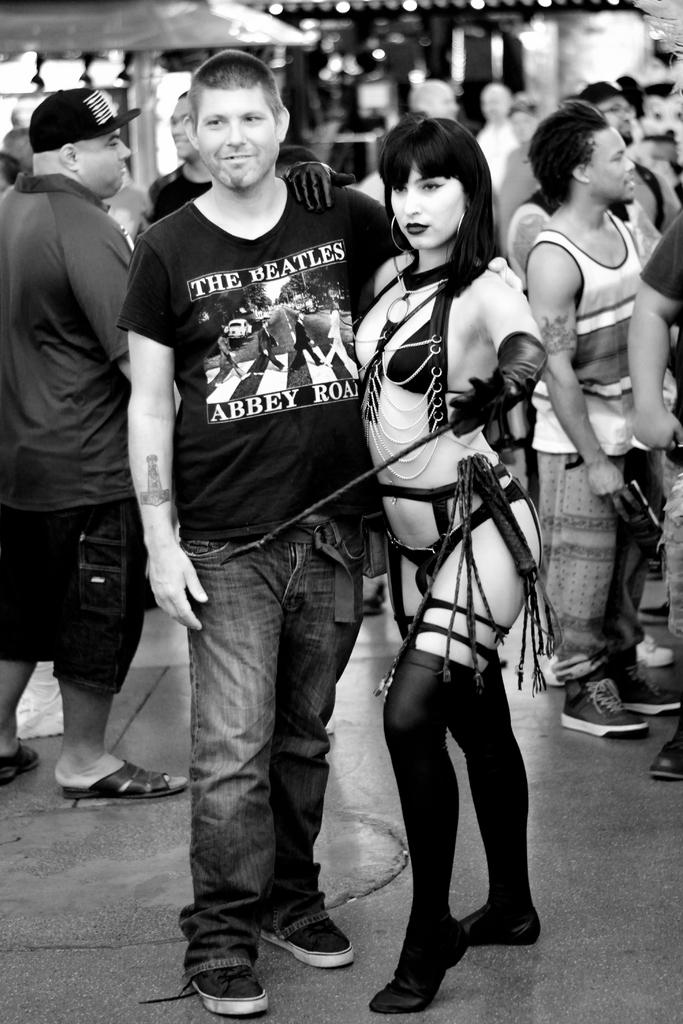Who are the main subjects in the foreground of the image? There is a man and a woman in the foreground of the image. What can be seen in the background of the image? There are people and roofs visible in the background of the image. What type of branch is the woman holding in the image? There is no branch present in the image. How many zippers can be seen on the man's clothing in the image? There is no mention of zippers or any specific clothing details in the image. 